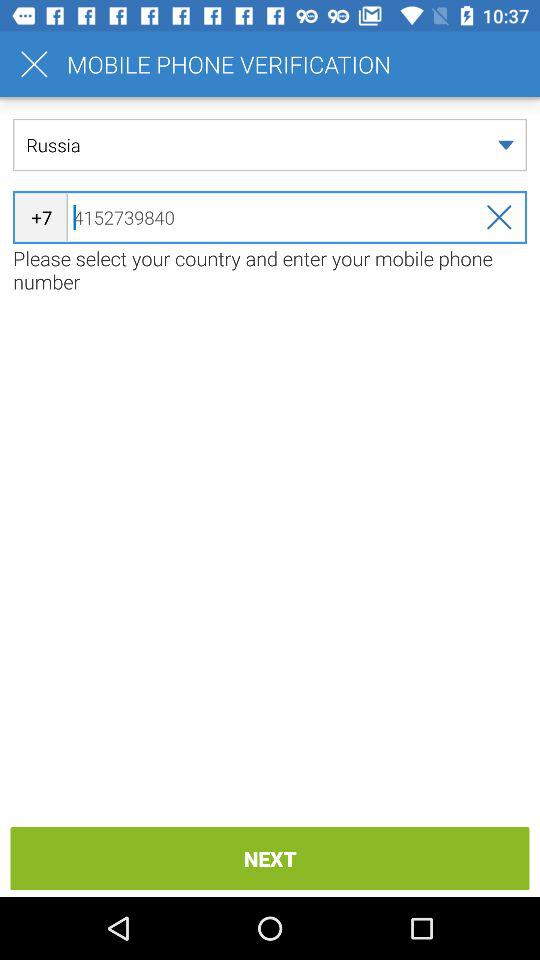What is the selected country's name? The selected country's name is Russia. 